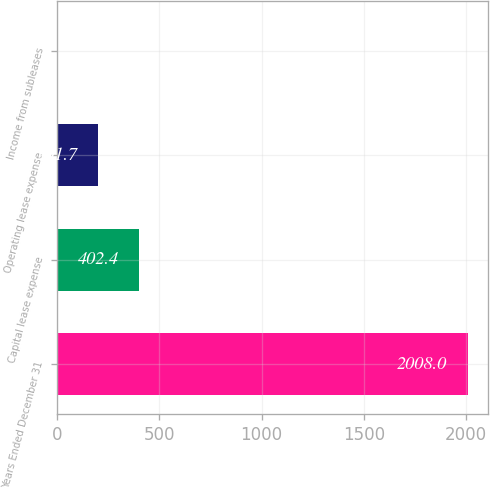Convert chart. <chart><loc_0><loc_0><loc_500><loc_500><bar_chart><fcel>Years Ended December 31<fcel>Capital lease expense<fcel>Operating lease expense<fcel>Income from subleases<nl><fcel>2008<fcel>402.4<fcel>201.7<fcel>1<nl></chart> 